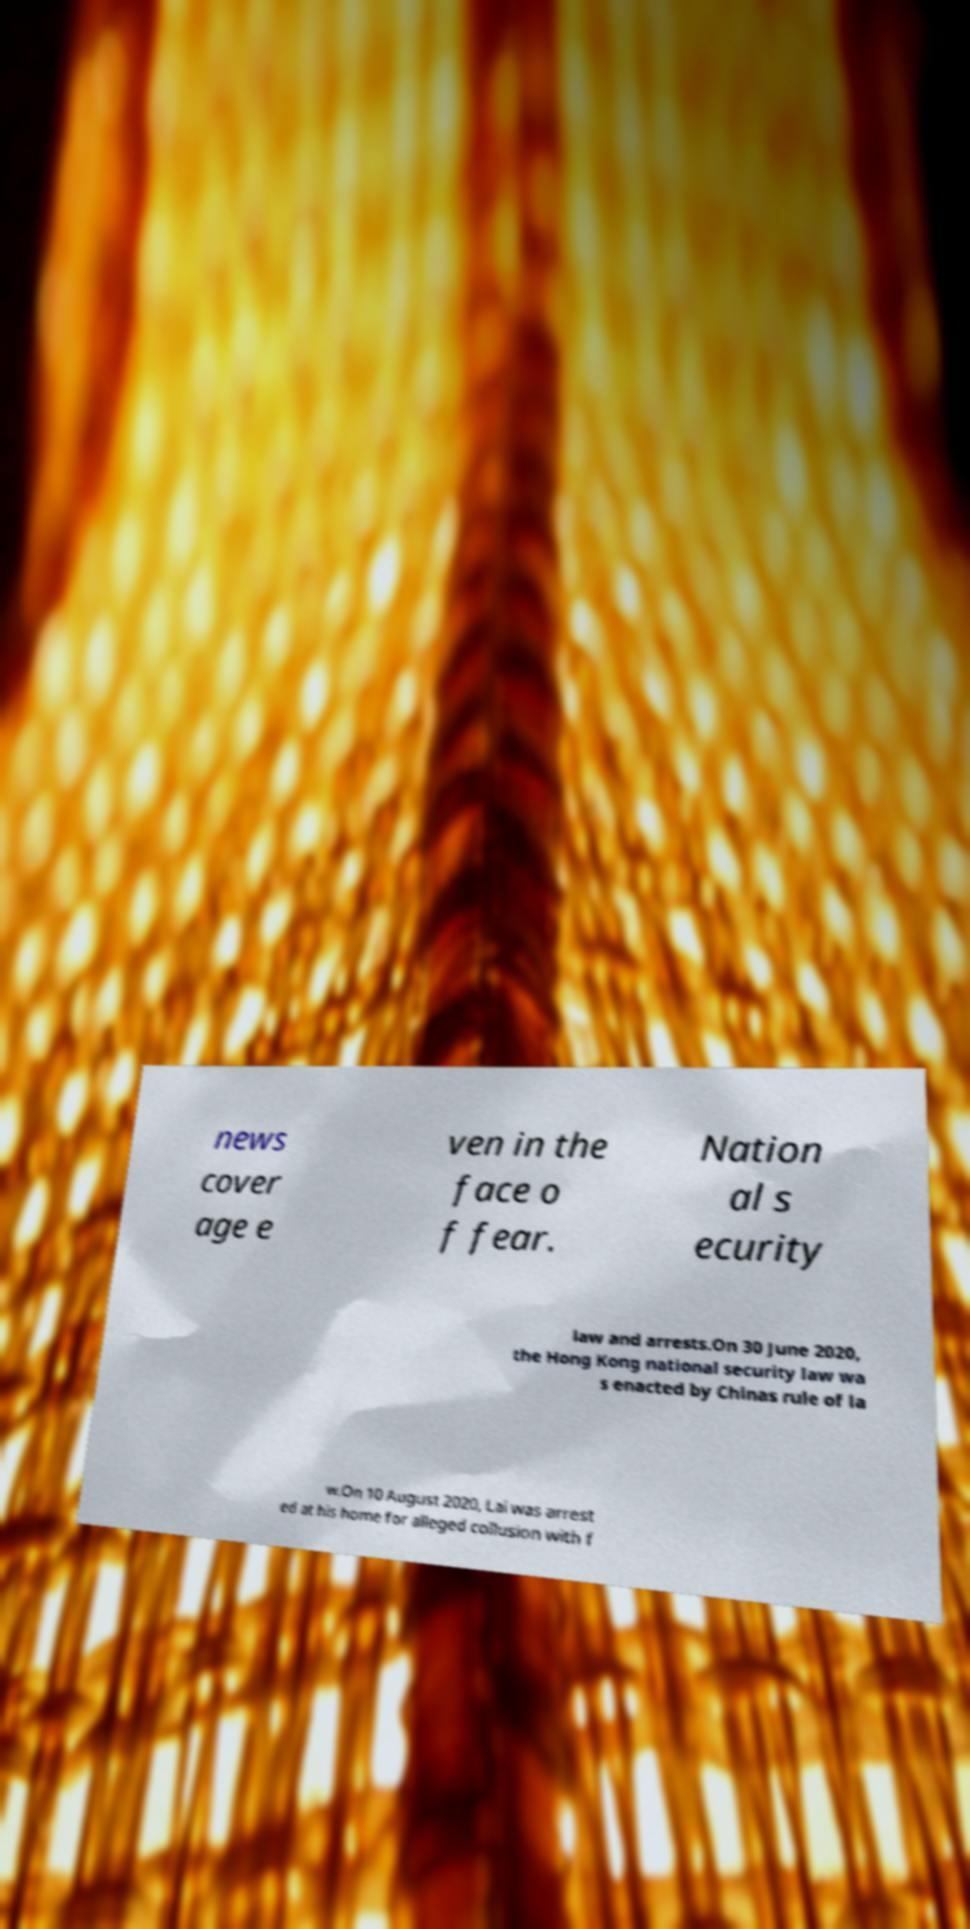Please read and relay the text visible in this image. What does it say? news cover age e ven in the face o f fear. Nation al s ecurity law and arrests.On 30 June 2020, the Hong Kong national security law wa s enacted by Chinas rule of la w.On 10 August 2020, Lai was arrest ed at his home for alleged collusion with f 